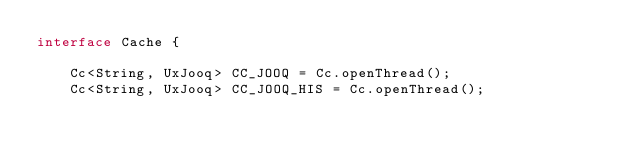Convert code to text. <code><loc_0><loc_0><loc_500><loc_500><_Java_>interface Cache {

    Cc<String, UxJooq> CC_JOOQ = Cc.openThread();
    Cc<String, UxJooq> CC_JOOQ_HIS = Cc.openThread();</code> 